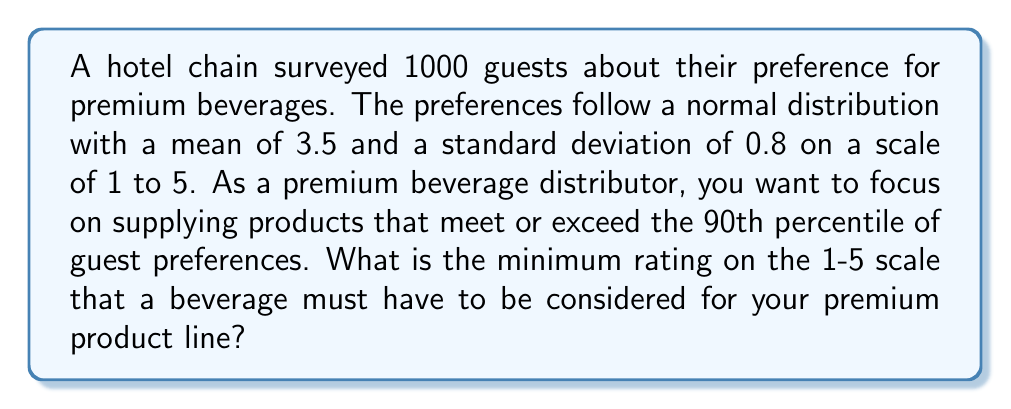Give your solution to this math problem. To solve this problem, we need to use the properties of the normal distribution and find the z-score corresponding to the 90th percentile. Then, we can convert this z-score back to the original scale.

Step 1: Determine the z-score for the 90th percentile.
The z-score for the 90th percentile is 1.28 (this is a standard value in z-score tables).

Step 2: Use the z-score formula to find the corresponding rating.
The z-score formula is:
$$ z = \frac{x - \mu}{\sigma} $$
Where:
$z$ = z-score (1.28)
$x$ = rating we're looking for
$\mu$ = mean (3.5)
$\sigma$ = standard deviation (0.8)

Plugging in the values:
$$ 1.28 = \frac{x - 3.5}{0.8} $$

Step 3: Solve for x.
Multiply both sides by 0.8:
$$ 1.28 * 0.8 = x - 3.5 $$
$$ 1.024 = x - 3.5 $$

Add 3.5 to both sides:
$$ x = 1.024 + 3.5 = 4.524 $$

Step 4: Round to two decimal places, as the original scale uses one decimal place.
The minimum rating for the premium product line is 4.52 on the 1-5 scale.
Answer: 4.52 